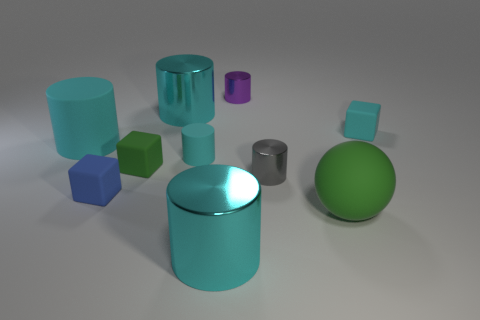Subtract all cyan cubes. How many cyan cylinders are left? 4 Subtract all large cyan rubber cylinders. How many cylinders are left? 5 Subtract all purple cylinders. How many cylinders are left? 5 Subtract all blue cylinders. Subtract all green balls. How many cylinders are left? 6 Subtract all blocks. How many objects are left? 7 Subtract all cyan shiny cylinders. Subtract all gray things. How many objects are left? 7 Add 7 tiny cyan objects. How many tiny cyan objects are left? 9 Add 1 big cyan rubber objects. How many big cyan rubber objects exist? 2 Subtract 0 brown spheres. How many objects are left? 10 